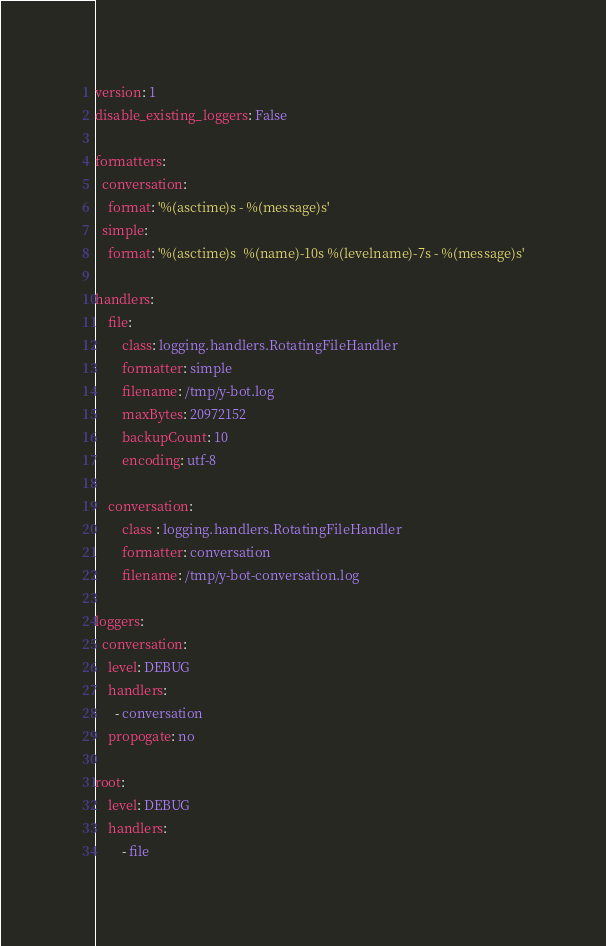Convert code to text. <code><loc_0><loc_0><loc_500><loc_500><_YAML_>version: 1
disable_existing_loggers: False

formatters:
  conversation:
    format: '%(asctime)s - %(message)s'
  simple:
    format: '%(asctime)s  %(name)-10s %(levelname)-7s - %(message)s'

handlers:
    file:
        class: logging.handlers.RotatingFileHandler
        formatter: simple
        filename: /tmp/y-bot.log
        maxBytes: 20972152
        backupCount: 10
        encoding: utf-8

    conversation:
        class : logging.handlers.RotatingFileHandler
        formatter: conversation
        filename: /tmp/y-bot-conversation.log

loggers:
  conversation:
    level: DEBUG
    handlers:
      - conversation
    propogate: no

root:
    level: DEBUG
    handlers:
        - file

</code> 